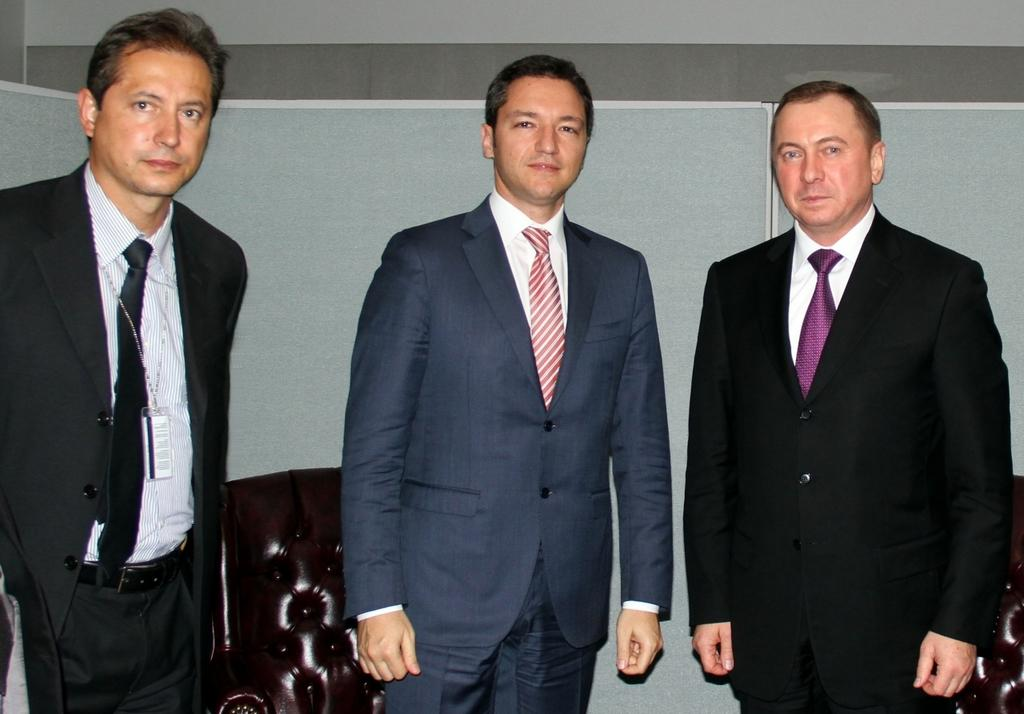How many people are in the image? There are three persons in the image. What are the people in the image doing? The three persons are standing. What are the people wearing around their necks? Each person is wearing a tie. How many frogs can be seen kissing in the image? There are no frogs or kissing depicted in the image. What is the average income of the people in the image? The provided facts do not include information about the people's income, so it cannot be determined from the image. 